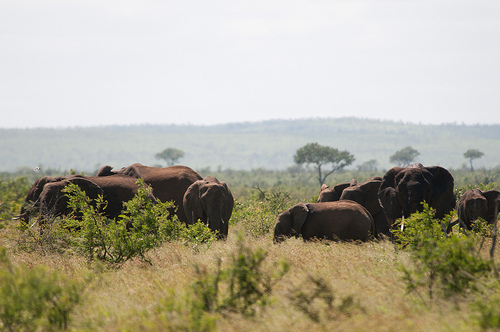How do the elephants typically interact in this kind of environment? Elephants in this environment often form tight-knit family groups, seeking shade under scattered trees and grazing together, which helps in maintaining social bonds and protection from predators. What adaptations do elephants have for living in such environments? Their large ears are not just for hearing; they act like radiators to help regulate body temperature. The tough skin and sparse hair minimize water loss, and their versatile trunks are used for foraging and water consumption. 